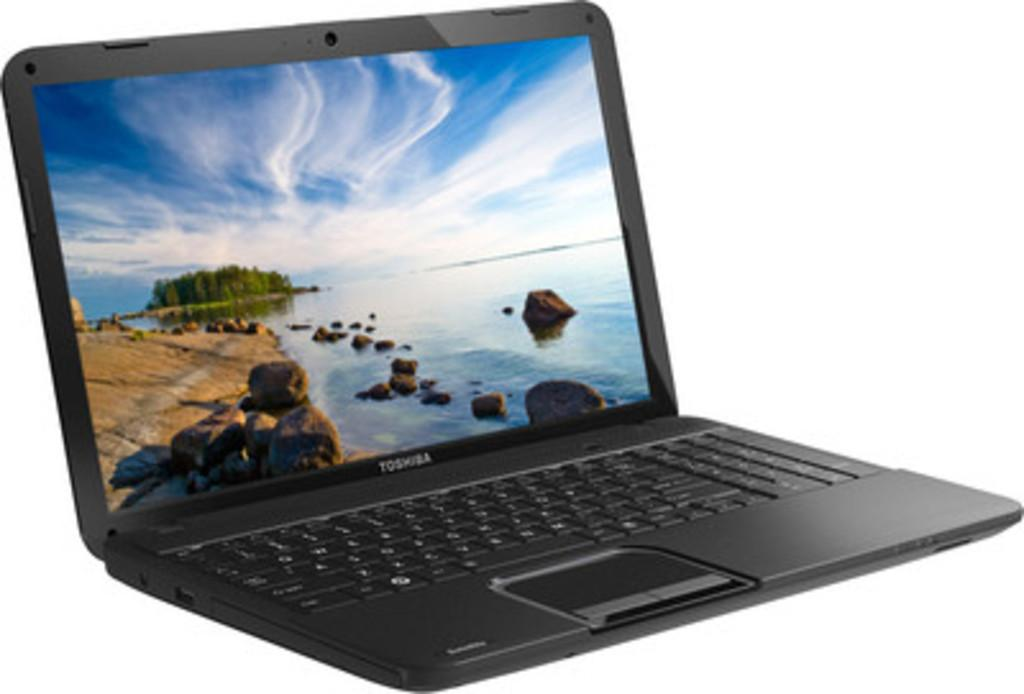What type of electronic device is in the picture? There is a black laptop in the picture. What brand is the laptop? The laptop is from Toshiba company. What color is the background of the laptop? The background of the laptop is white. What type of branch can be seen on the laptop's keyboard in the image? There is no branch present on the laptop's keyboard in the image. What scale is used to measure the laptop's weight in the image? There is no scale present in the image to measure the laptop's weight. 